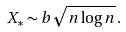<formula> <loc_0><loc_0><loc_500><loc_500>X _ { * } \sim b \sqrt { n \log { n } } \, .</formula> 